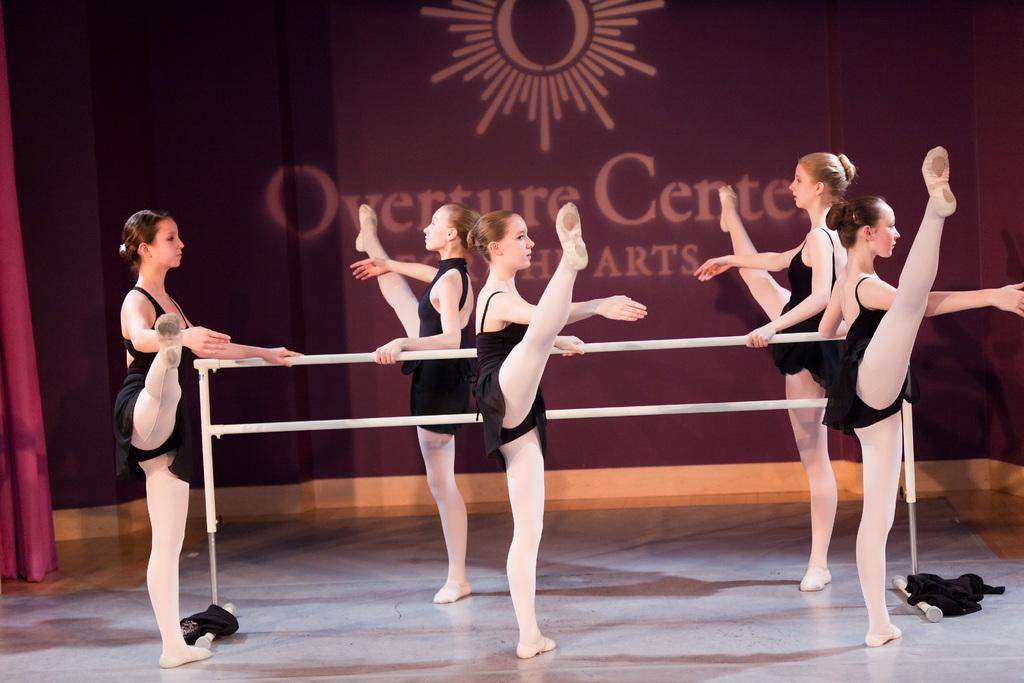What are the people in the image doing? The people in the image are doing gymnastics. What are the people wearing while doing gymnastics? The people are wearing black dresses. What can be seen in the background of the image? There is a wall in the background of the image. What color is the wall in the image? The wall is in maroon color. What type of key is being used to unlock the door in the image? There is no door or key present in the image; it features a group of people doing gymnastics in front of a maroon wall. How many slaves are visible in the image? There are no slaves present in the image; it features a group of people doing gymnastics in front of a maroon wall. 